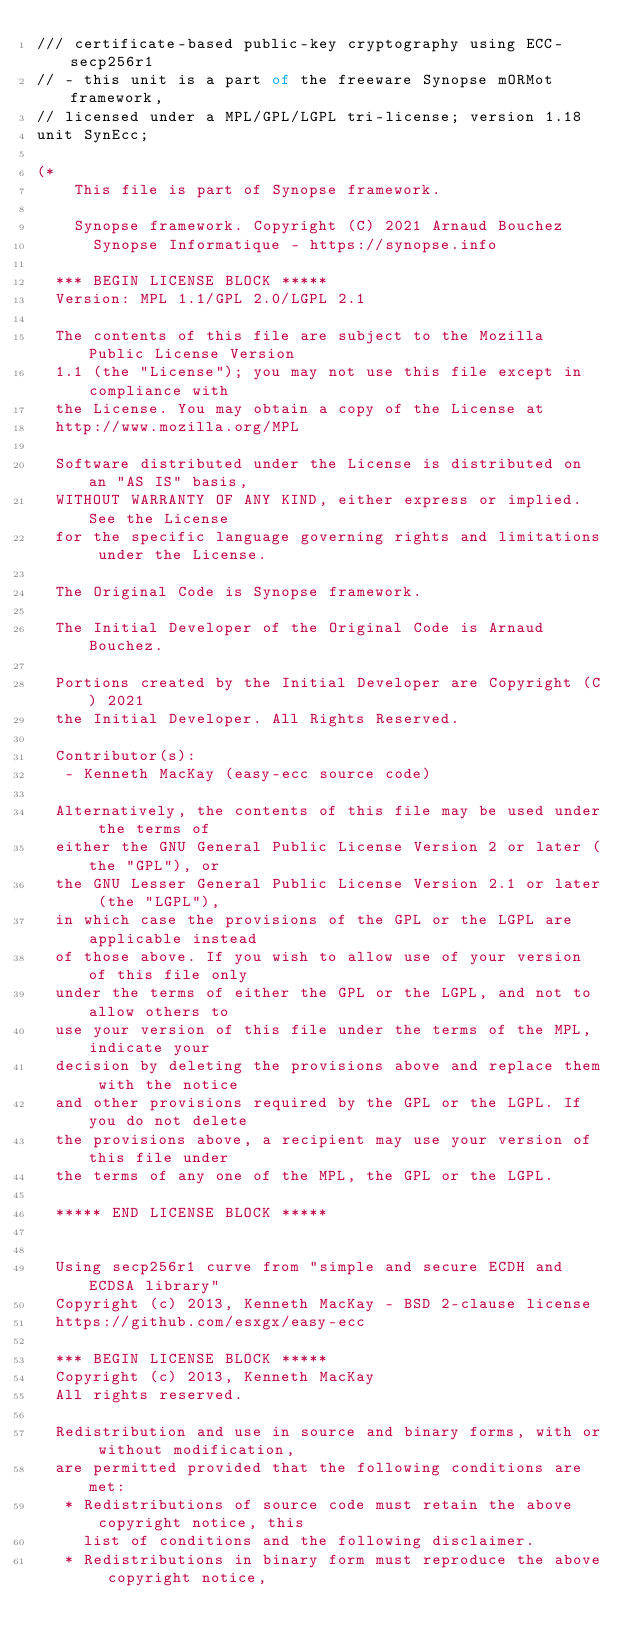Convert code to text. <code><loc_0><loc_0><loc_500><loc_500><_Pascal_>/// certificate-based public-key cryptography using ECC-secp256r1
// - this unit is a part of the freeware Synopse mORMot framework,
// licensed under a MPL/GPL/LGPL tri-license; version 1.18
unit SynEcc;

(*
    This file is part of Synopse framework.

    Synopse framework. Copyright (C) 2021 Arnaud Bouchez
      Synopse Informatique - https://synopse.info

  *** BEGIN LICENSE BLOCK *****
  Version: MPL 1.1/GPL 2.0/LGPL 2.1

  The contents of this file are subject to the Mozilla Public License Version
  1.1 (the "License"); you may not use this file except in compliance with
  the License. You may obtain a copy of the License at
  http://www.mozilla.org/MPL

  Software distributed under the License is distributed on an "AS IS" basis,
  WITHOUT WARRANTY OF ANY KIND, either express or implied. See the License
  for the specific language governing rights and limitations under the License.

  The Original Code is Synopse framework.

  The Initial Developer of the Original Code is Arnaud Bouchez.

  Portions created by the Initial Developer are Copyright (C) 2021
  the Initial Developer. All Rights Reserved.

  Contributor(s):
   - Kenneth MacKay (easy-ecc source code)

  Alternatively, the contents of this file may be used under the terms of
  either the GNU General Public License Version 2 or later (the "GPL"), or
  the GNU Lesser General Public License Version 2.1 or later (the "LGPL"),
  in which case the provisions of the GPL or the LGPL are applicable instead
  of those above. If you wish to allow use of your version of this file only
  under the terms of either the GPL or the LGPL, and not to allow others to
  use your version of this file under the terms of the MPL, indicate your
  decision by deleting the provisions above and replace them with the notice
  and other provisions required by the GPL or the LGPL. If you do not delete
  the provisions above, a recipient may use your version of this file under
  the terms of any one of the MPL, the GPL or the LGPL.

  ***** END LICENSE BLOCK *****


  Using secp256r1 curve from "simple and secure ECDH and ECDSA library"
  Copyright (c) 2013, Kenneth MacKay - BSD 2-clause license
  https://github.com/esxgx/easy-ecc

  *** BEGIN LICENSE BLOCK *****
  Copyright (c) 2013, Kenneth MacKay
  All rights reserved.

  Redistribution and use in source and binary forms, with or without modification,
  are permitted provided that the following conditions are met:
   * Redistributions of source code must retain the above copyright notice, this
     list of conditions and the following disclaimer.
   * Redistributions in binary form must reproduce the above copyright notice,</code> 